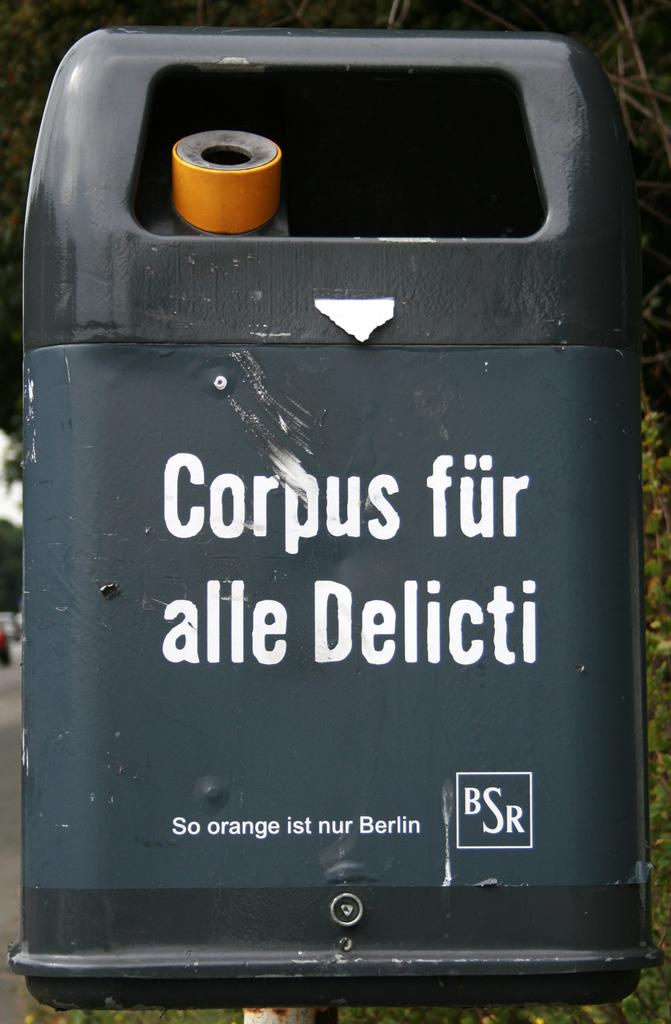<image>
Relay a brief, clear account of the picture shown. A trash bin has the initials BSR at the bottom in a rectangle. 